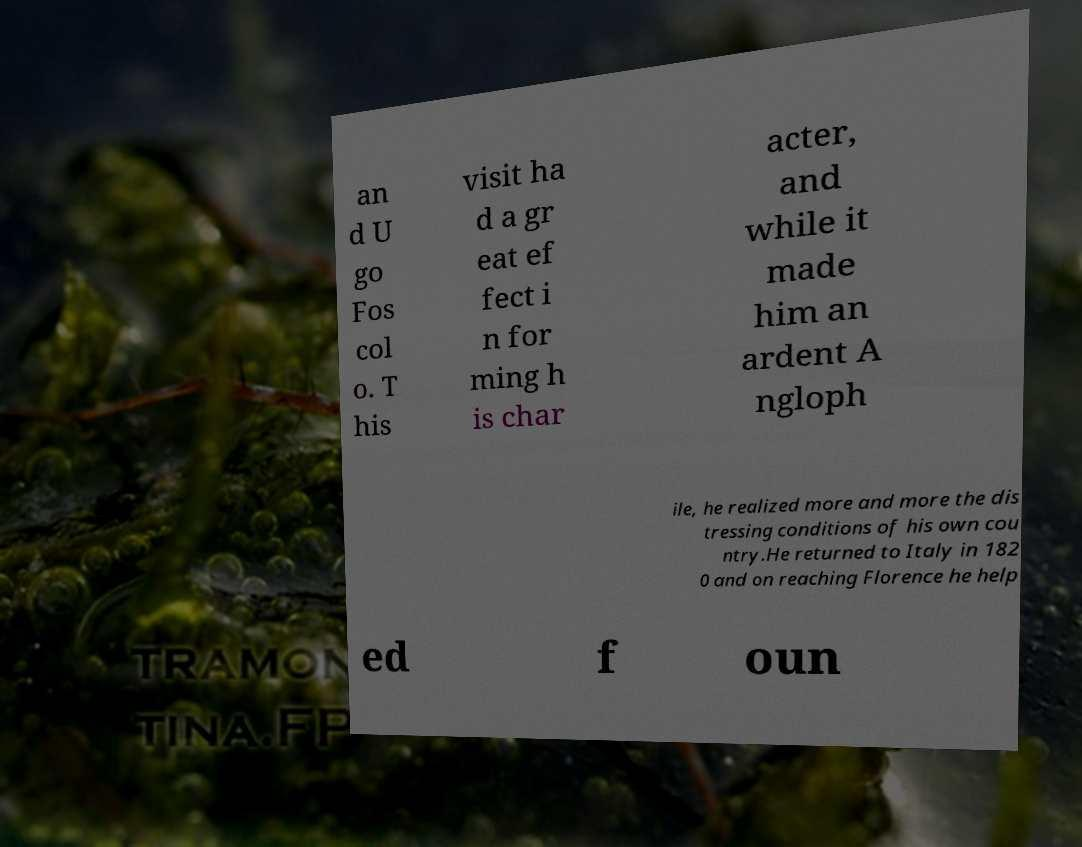Please identify and transcribe the text found in this image. an d U go Fos col o. T his visit ha d a gr eat ef fect i n for ming h is char acter, and while it made him an ardent A ngloph ile, he realized more and more the dis tressing conditions of his own cou ntry.He returned to Italy in 182 0 and on reaching Florence he help ed f oun 